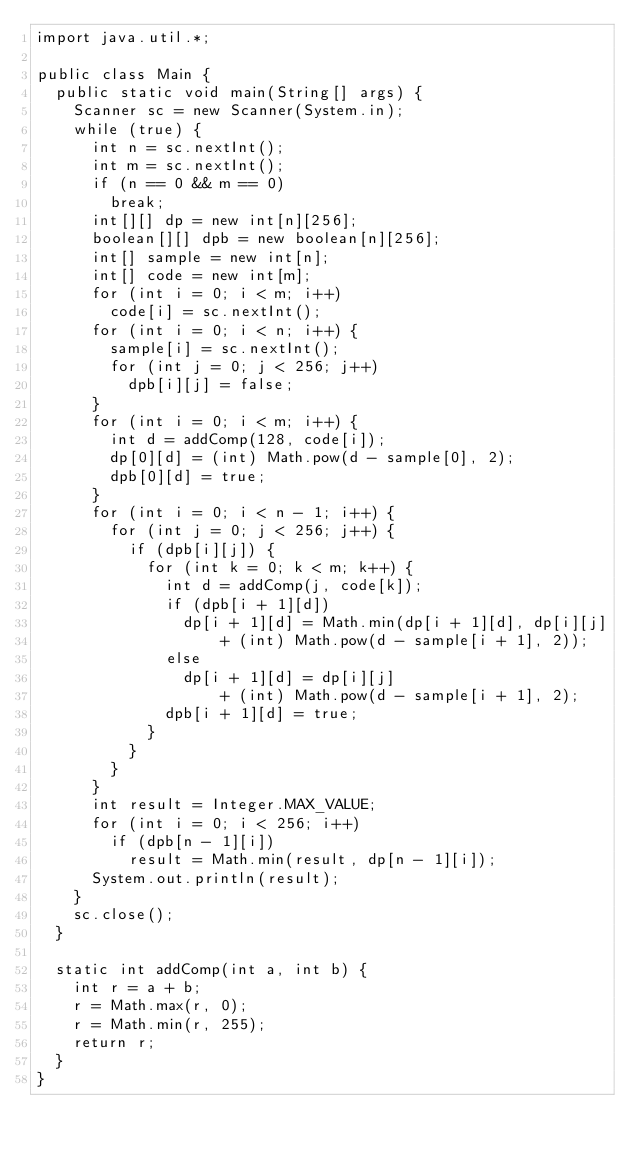<code> <loc_0><loc_0><loc_500><loc_500><_Java_>import java.util.*;

public class Main {
	public static void main(String[] args) {
		Scanner sc = new Scanner(System.in);
		while (true) {
			int n = sc.nextInt();
			int m = sc.nextInt();
			if (n == 0 && m == 0)
				break;
			int[][] dp = new int[n][256];
			boolean[][] dpb = new boolean[n][256];
			int[] sample = new int[n];
			int[] code = new int[m];
			for (int i = 0; i < m; i++)
				code[i] = sc.nextInt();
			for (int i = 0; i < n; i++) {
				sample[i] = sc.nextInt();
				for (int j = 0; j < 256; j++)
					dpb[i][j] = false;
			}
			for (int i = 0; i < m; i++) {
				int d = addComp(128, code[i]);
				dp[0][d] = (int) Math.pow(d - sample[0], 2);
				dpb[0][d] = true;
			}
			for (int i = 0; i < n - 1; i++) {
				for (int j = 0; j < 256; j++) {
					if (dpb[i][j]) {
						for (int k = 0; k < m; k++) {
							int d = addComp(j, code[k]);
							if (dpb[i + 1][d])
								dp[i + 1][d] = Math.min(dp[i + 1][d], dp[i][j]
										+ (int) Math.pow(d - sample[i + 1], 2));
							else
								dp[i + 1][d] = dp[i][j]
										+ (int) Math.pow(d - sample[i + 1], 2);
							dpb[i + 1][d] = true;
						}
					}
				}
			}
			int result = Integer.MAX_VALUE;
			for (int i = 0; i < 256; i++)
				if (dpb[n - 1][i])
					result = Math.min(result, dp[n - 1][i]);
			System.out.println(result);
		}
		sc.close();
	}

	static int addComp(int a, int b) {
		int r = a + b;
		r = Math.max(r, 0);
		r = Math.min(r, 255);
		return r;
	}
}</code> 